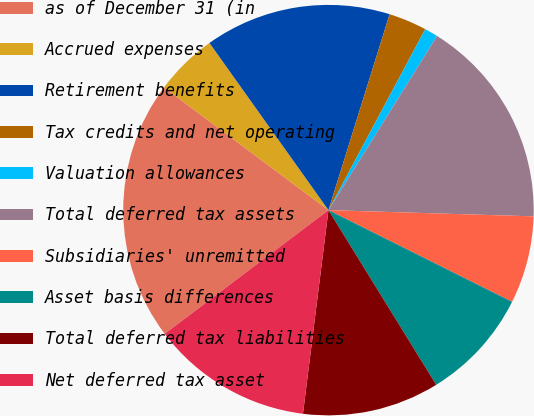<chart> <loc_0><loc_0><loc_500><loc_500><pie_chart><fcel>as of December 31 (in<fcel>Accrued expenses<fcel>Retirement benefits<fcel>Tax credits and net operating<fcel>Valuation allowances<fcel>Total deferred tax assets<fcel>Subsidiaries' unremitted<fcel>Asset basis differences<fcel>Total deferred tax liabilities<fcel>Net deferred tax asset<nl><fcel>20.5%<fcel>4.95%<fcel>14.66%<fcel>3.0%<fcel>1.06%<fcel>16.61%<fcel>6.89%<fcel>8.83%<fcel>10.78%<fcel>12.72%<nl></chart> 